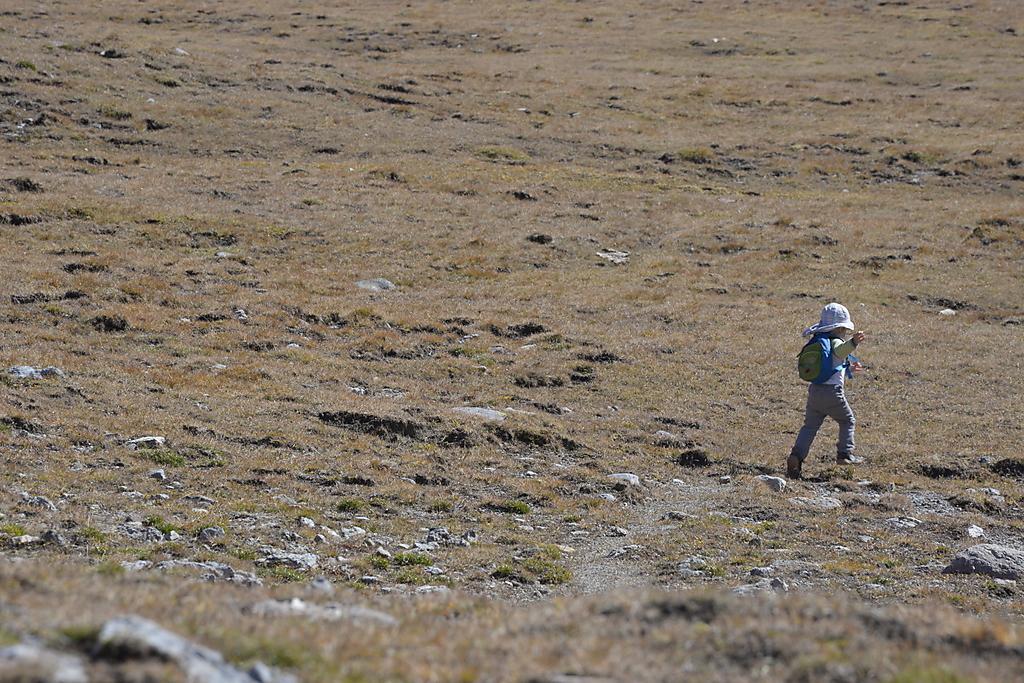Can you describe this image briefly? On the right a kid is running the ground by carrying a bag on the shoulders and there is a hat on the head and on the ground we can see grass and stones. 